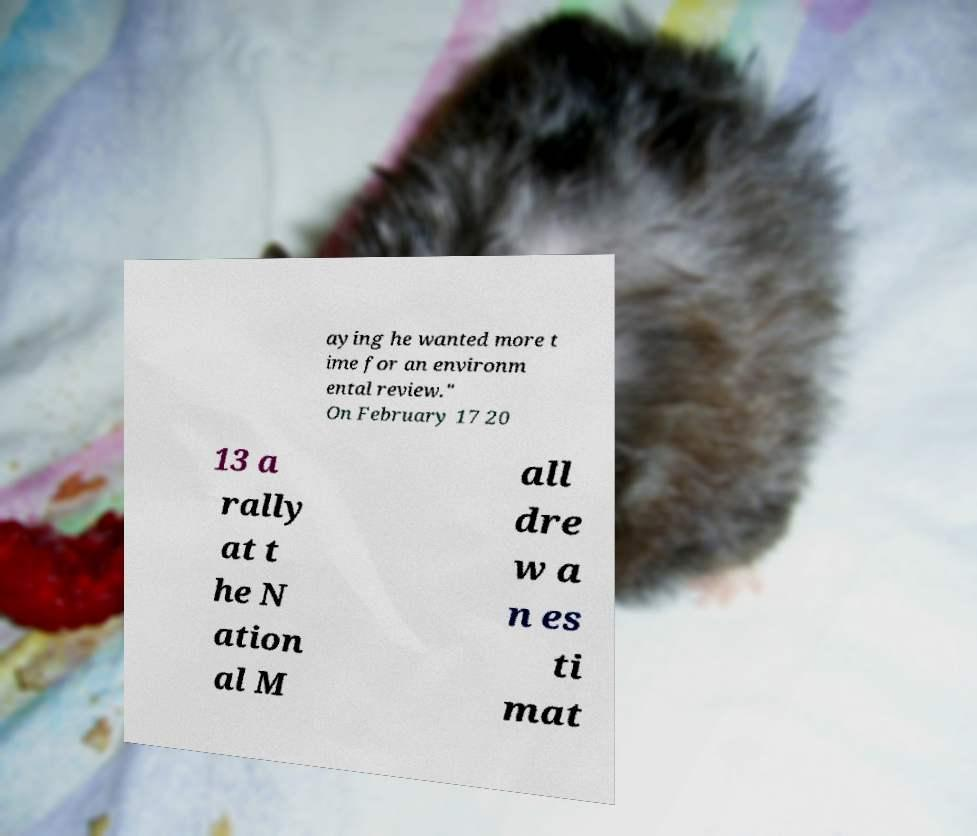There's text embedded in this image that I need extracted. Can you transcribe it verbatim? aying he wanted more t ime for an environm ental review." On February 17 20 13 a rally at t he N ation al M all dre w a n es ti mat 